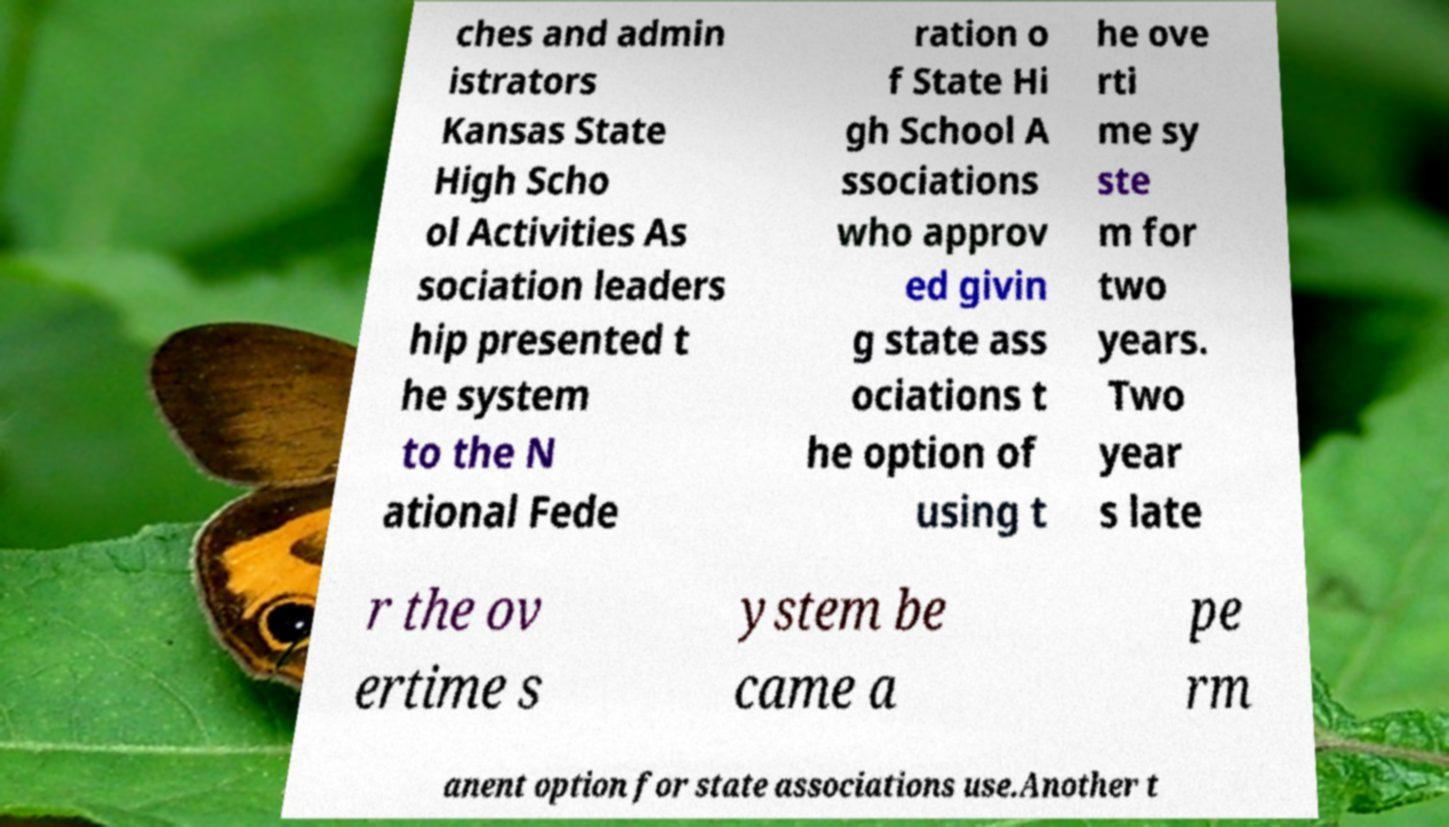For documentation purposes, I need the text within this image transcribed. Could you provide that? ches and admin istrators Kansas State High Scho ol Activities As sociation leaders hip presented t he system to the N ational Fede ration o f State Hi gh School A ssociations who approv ed givin g state ass ociations t he option of using t he ove rti me sy ste m for two years. Two year s late r the ov ertime s ystem be came a pe rm anent option for state associations use.Another t 